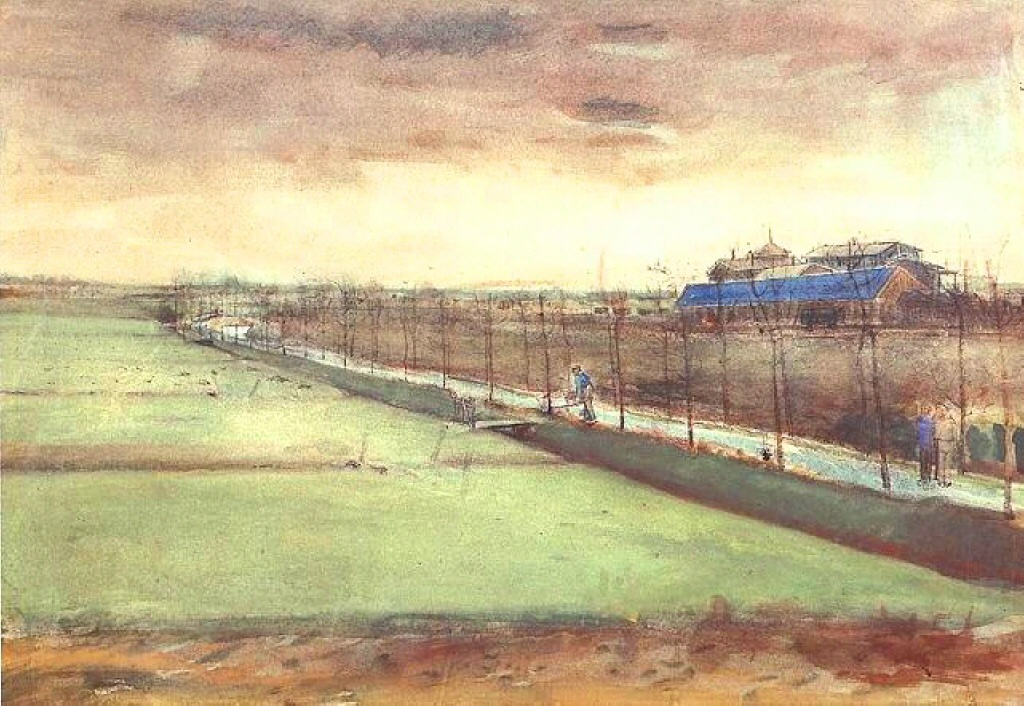What is this photo about? This image portrays a serene, rural landscape, likely painted in the impressionistic style. The central dirt road draws the viewer deeper into the scene, leading to a striking blue-roofed building. This building, amid a muted color palette of greens, browns, and soft sky blues, adds a vibrant contrast to the landscape. Overhead, the sky is teeming with heavy clouds, possibly suggesting an impending storm, which adds a dynamic element to the otherwise tranquil setting. Figures in the scene lend a human touch, suggesting daily life continues amidst this rural tranquility. This painting not only captures the physical aspects of the landscape but also evokes a sense of place and time, potentially inviting the viewer to ponder the lives of those dwelling within it. 